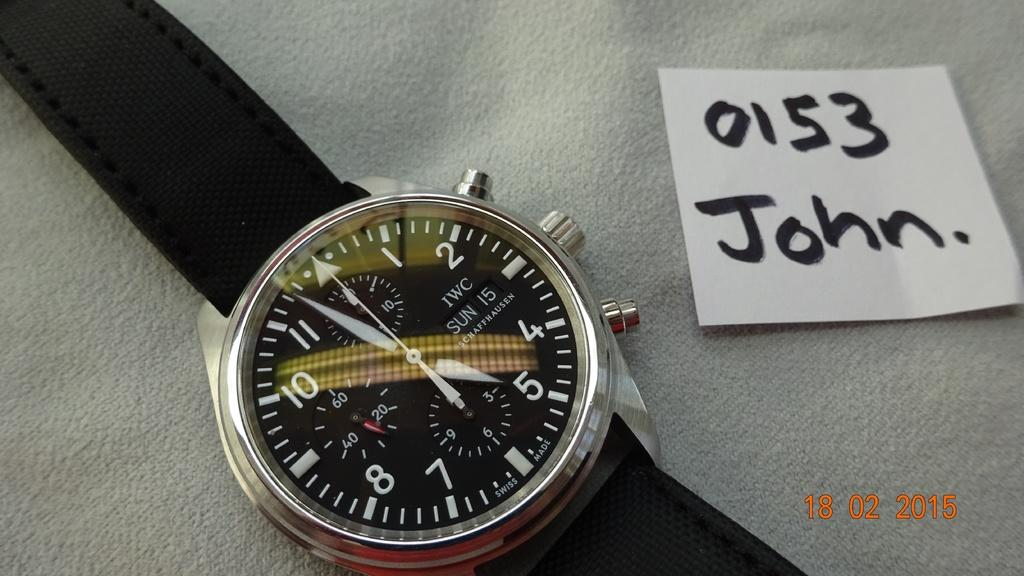<image>
Share a concise interpretation of the image provided. Black and silver catch with a piece of paper which says 0153 John on it. 